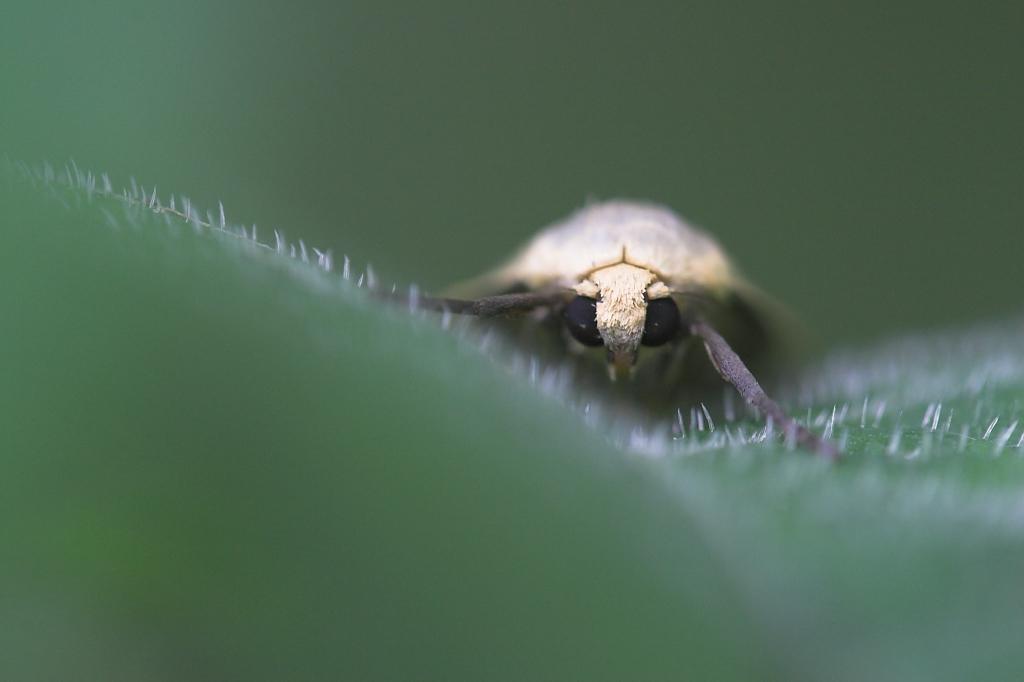How would you summarize this image in a sentence or two? In this image we can see an insect on a green surface. In the background of the image there is a blur background. 